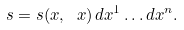<formula> <loc_0><loc_0><loc_500><loc_500>\ s = s ( x , \ x ) \, d x ^ { 1 } \dots d x ^ { n } .</formula> 